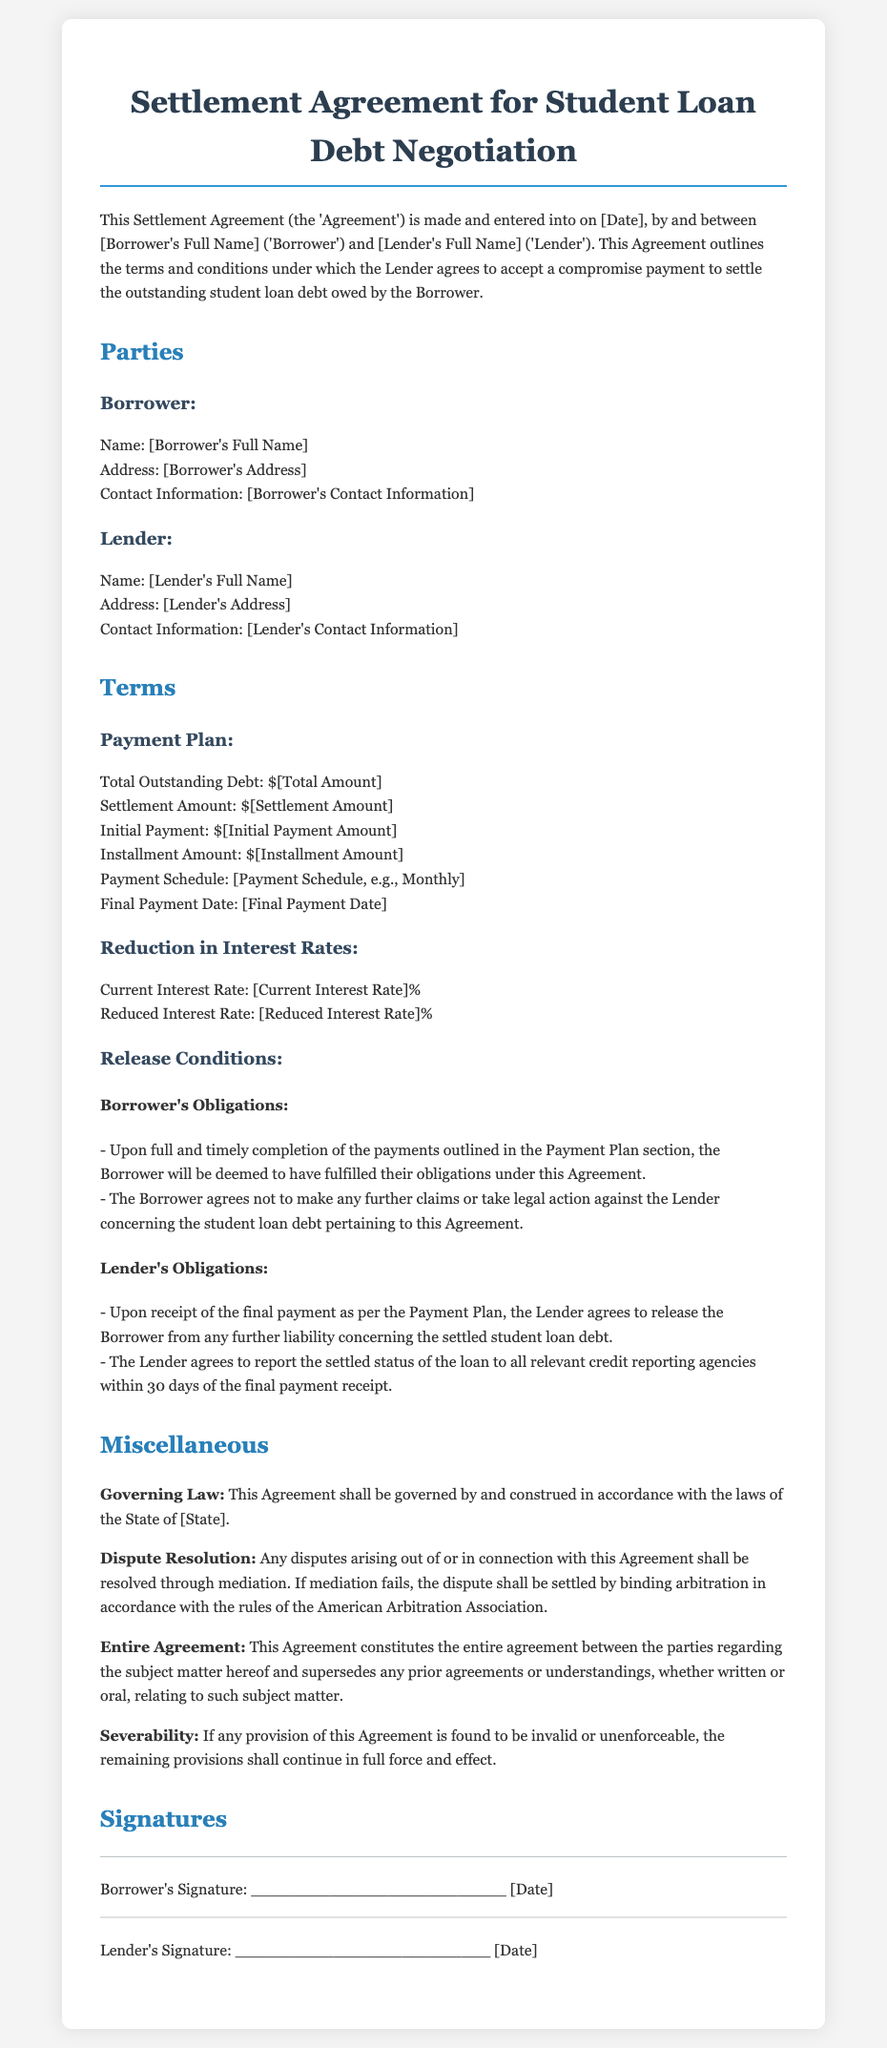What is the Borrower's full name? The Borrower's full name is explicitly stated in the document under the parties' section.
Answer: [Borrower's Full Name] What is the total outstanding debt? The total outstanding debt is provided in the payment plan details of the agreement.
Answer: $[Total Amount] What is the reduced interest rate? The reduced interest rate is specified in the terms section under the reduction in interest rates.
Answer: [Reduced Interest Rate]% What condition must the Borrower fulfill for release? The condition for release is tied to the completion of payments as detailed in the release conditions.
Answer: Completion of payments What is the governing law for this Agreement? The governing law is mentioned in the miscellaneous section of the contract.
Answer: State of [State] What steps are outlined for dispute resolution? The steps for dispute resolution include mediation and, if necessary, binding arbitration.
Answer: Mediation, binding arbitration What is the final payment date? The final payment date is a specific detail mentioned in the payment plan of the document.
Answer: [Final Payment Date] What is the initial payment amount? The initial payment amount is listed in the terms section of the agreement.
Answer: $[Initial Payment Amount] What type of disputes will this Agreement resolve? The Agreement specifies the type of disputes to be resolved, given its context.
Answer: Disputes arising from this Agreement 